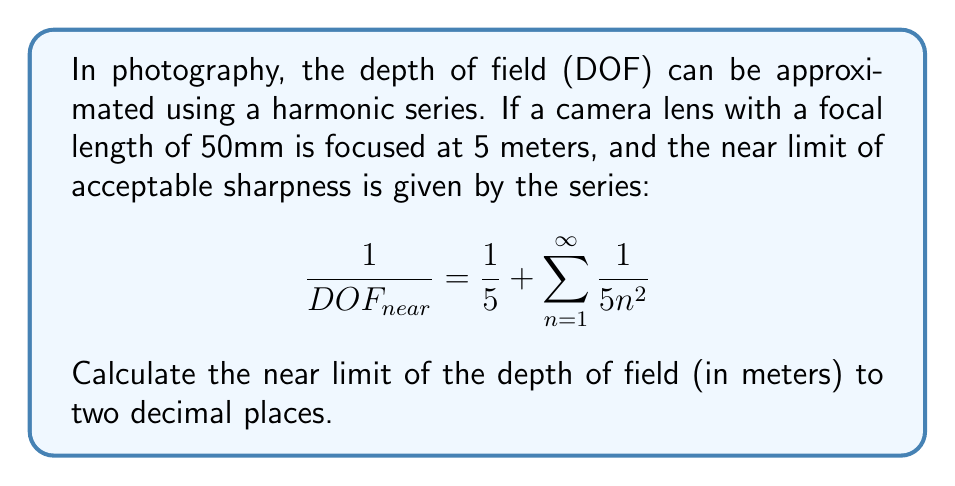Can you solve this math problem? To solve this problem, we'll follow these steps:

1) First, recognize that the series $\sum_{n=1}^{\infty} \frac{1}{n^2}$ is a well-known series called the Basel problem. Its sum is $\frac{\pi^2}{6}$.

2) Therefore, our equation becomes:

   $$\frac{1}{DOF_{near}} = \frac{1}{5} + \frac{1}{5} \cdot \frac{\pi^2}{6}$$

3) Simplify:
   $$\frac{1}{DOF_{near}} = \frac{1}{5} \cdot (1 + \frac{\pi^2}{6})$$

4) Calculate $\frac{\pi^2}{6}$:
   $$\frac{\pi^2}{6} \approx 1.6449$$

5) Substitute this value:
   $$\frac{1}{DOF_{near}} = \frac{1}{5} \cdot (1 + 1.6449) = \frac{2.6449}{5} = 0.52898$$

6) To get $DOF_{near}$, we take the reciprocal:
   $$DOF_{near} = \frac{1}{0.52898} \approx 1.8904$$

7) Rounding to two decimal places:
   $$DOF_{near} \approx 1.89\text{ meters}$$
Answer: 1.89 meters 